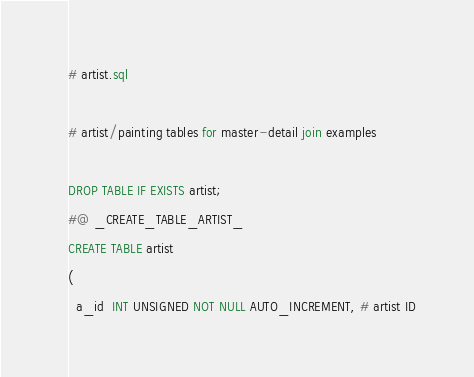<code> <loc_0><loc_0><loc_500><loc_500><_SQL_># artist.sql

# artist/painting tables for master-detail join examples

DROP TABLE IF EXISTS artist;
#@ _CREATE_TABLE_ARTIST_
CREATE TABLE artist
(
  a_id  INT UNSIGNED NOT NULL AUTO_INCREMENT, # artist ID</code> 